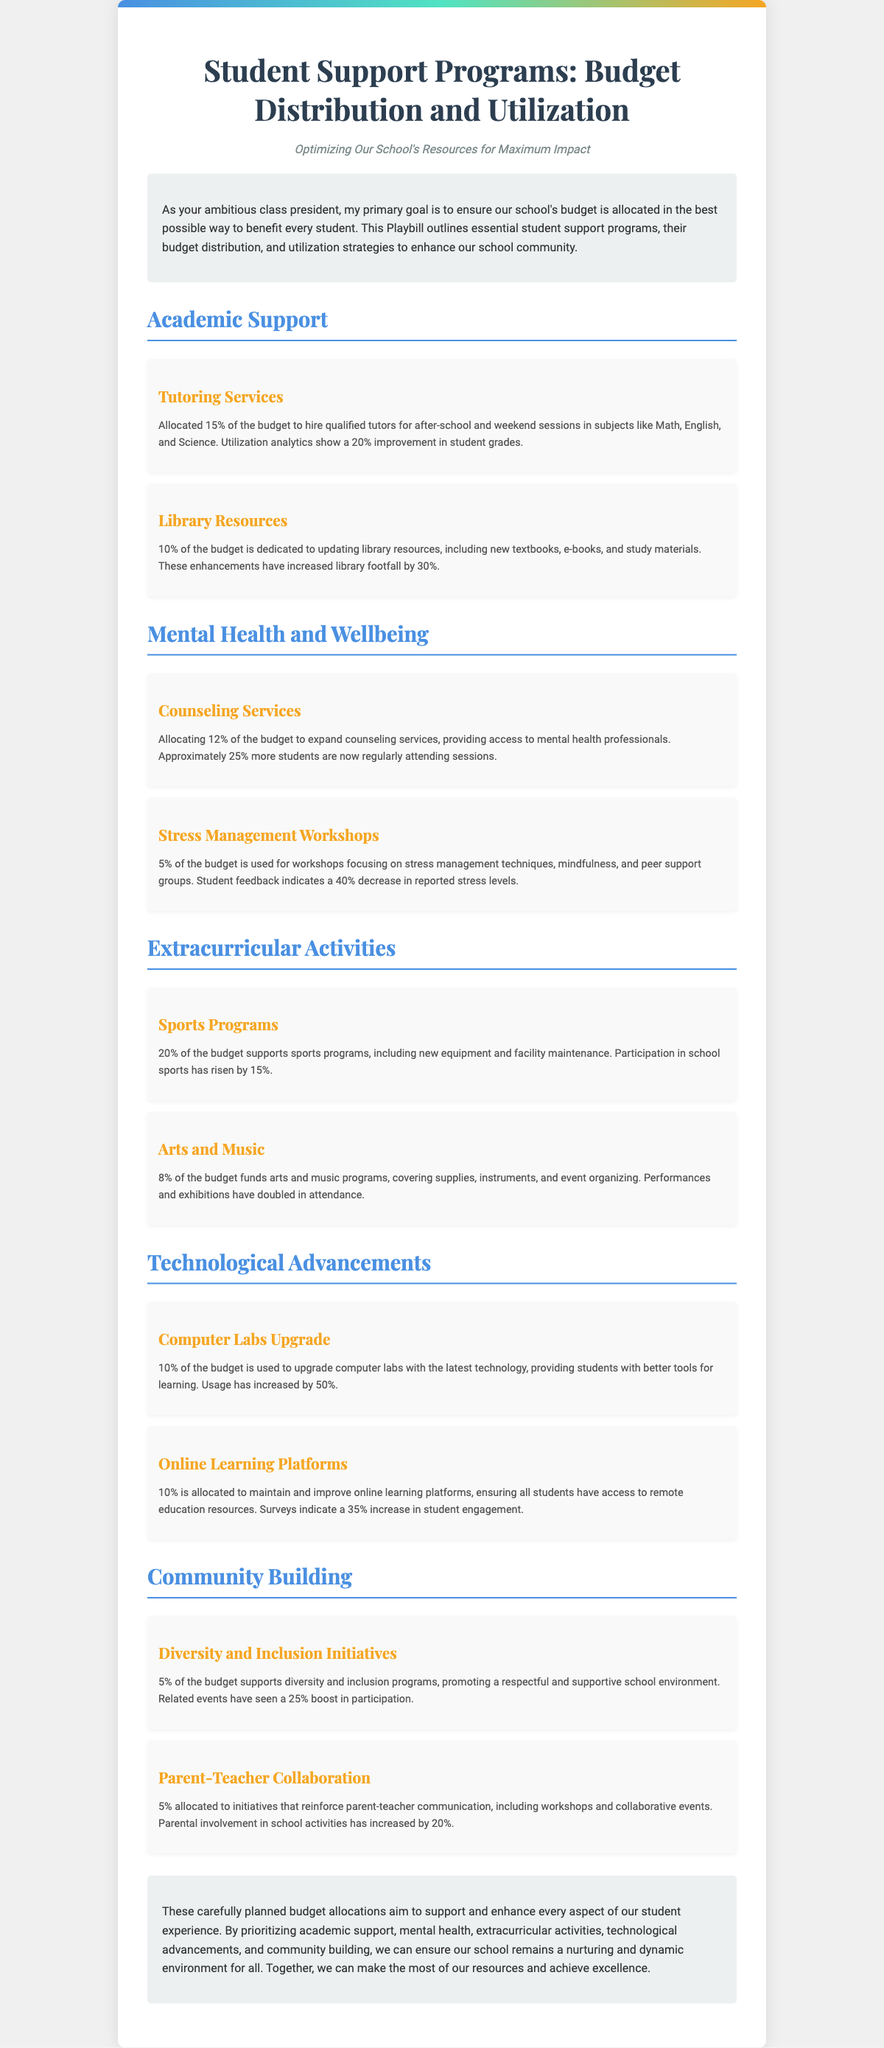what percentage of the budget is allocated to tutoring services? The document states that 15% of the budget is allocated to tutoring services.
Answer: 15% how much has library footfall increased? According to the document, library footfall has increased by 30%.
Answer: 30% what is the budget allocation for counseling services? The document mentions that 12% of the budget is allocated to counseling services.
Answer: 12% which program uses 5% of the budget for workshops? The document states that the Stress Management Workshops use 5% of the budget.
Answer: Stress Management Workshops how has participation in school sports changed? The document reports a 15% rise in participation in school sports.
Answer: 15% what is the budget percentage designated for arts and music programs? The document indicates that 8% of the budget funds arts and music programs.
Answer: 8% how much has usage increased in the computer labs after the upgrade? According to the document, usage has increased by 50%.
Answer: 50% what is the goal of the diversity and inclusion initiatives? The document states the goal is to promote a respectful and supportive school environment.
Answer: Promote a respectful and supportive school environment what is the title of the document? The document is titled "Student Support Programs: Budget Distribution and Utilization."
Answer: Student Support Programs: Budget Distribution and Utilization 